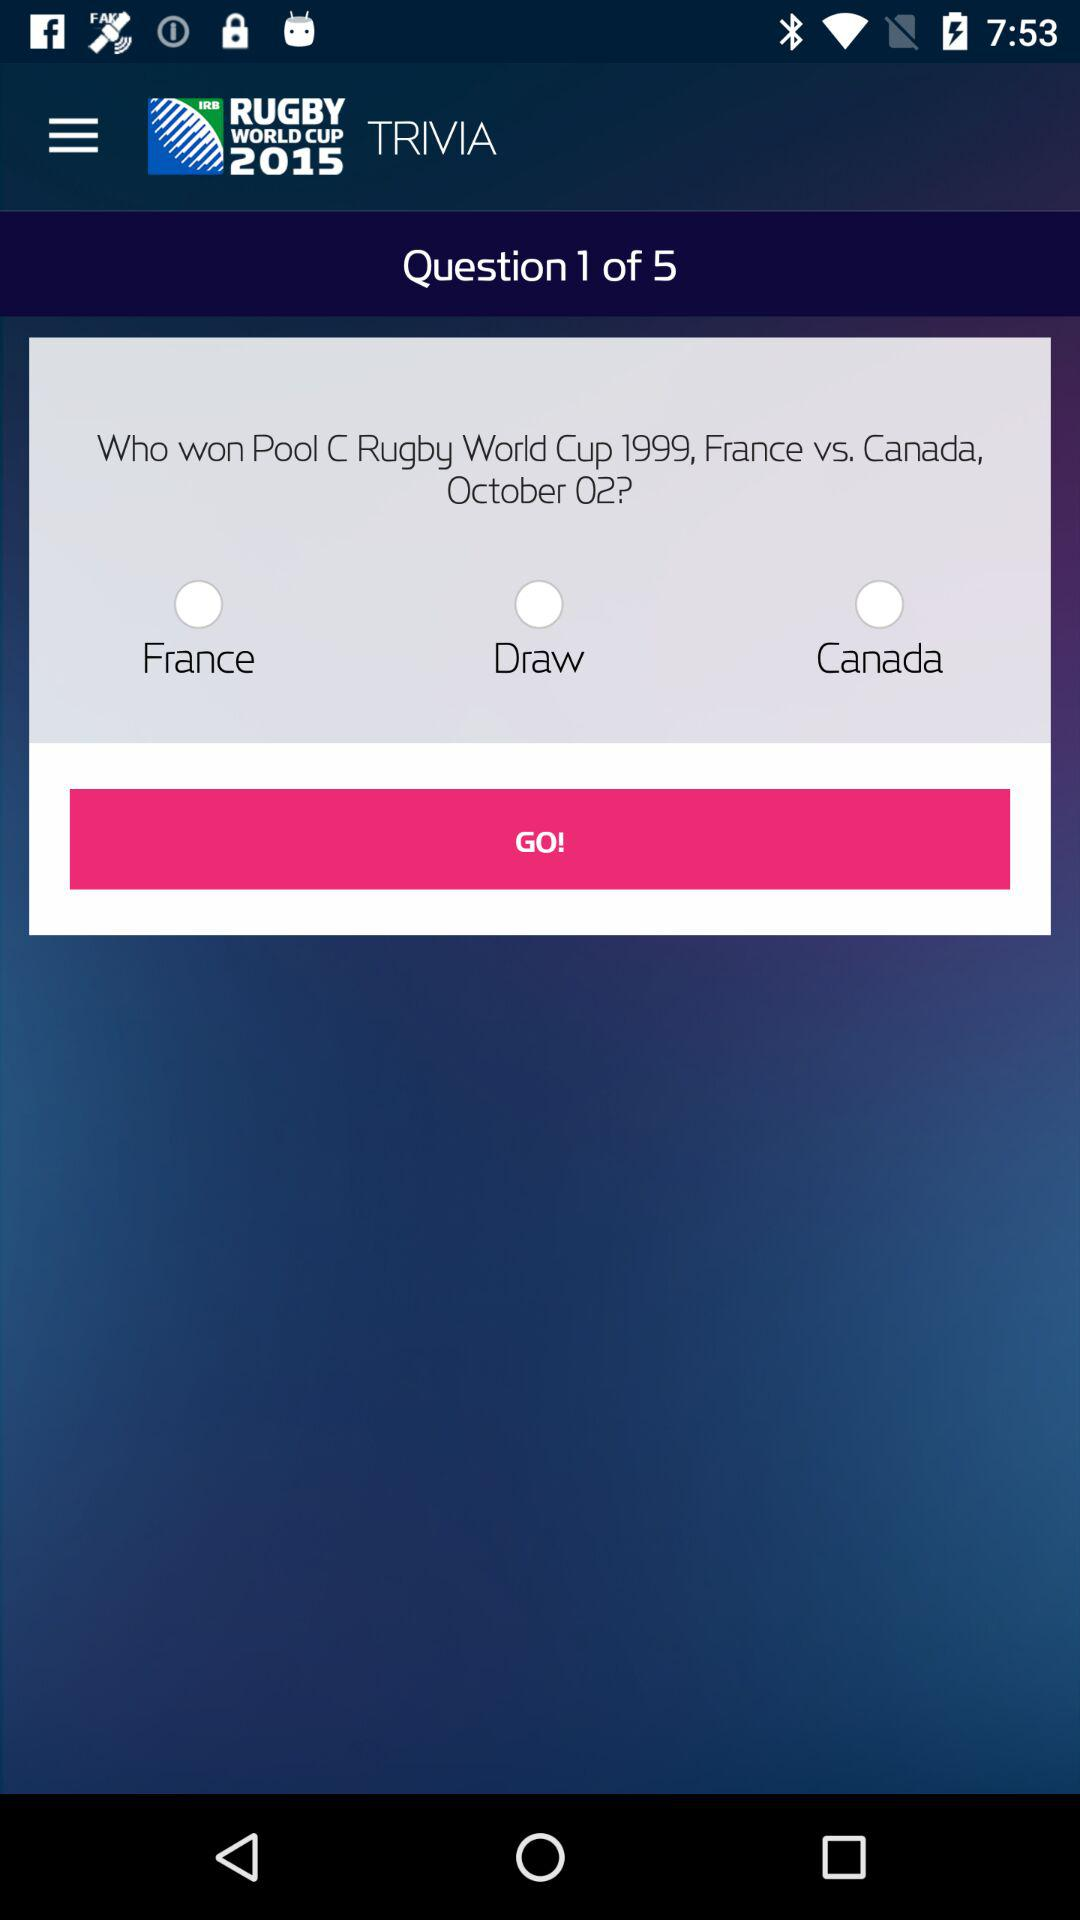How many answers are there to the trivia question?
Answer the question using a single word or phrase. 3 